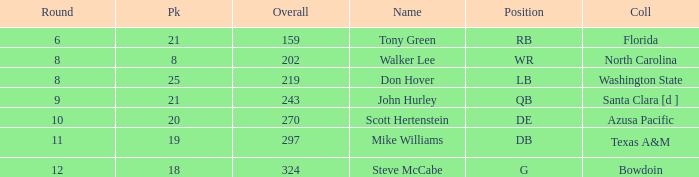What college has an overall less than 243, and tony green as the name? Florida. 